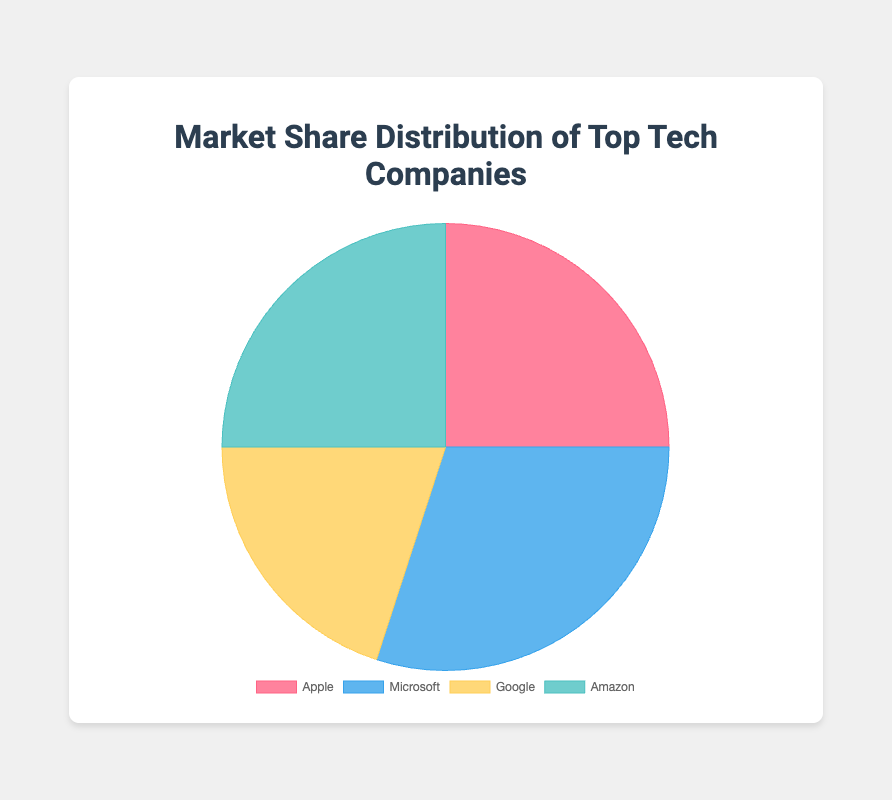What is the total market share percentage of Apple and Amazon combined? Add the market share percentages of Apple (25) and Amazon (25). 25 + 25 = 50
Answer: 50 Which company holds the highest market share? Compare the market share percentages: Apple (25), Microsoft (30), Google (20), Amazon (25). Microsoft has the highest with 30%
Answer: Microsoft What is the difference in market share between Microsoft and Google? Subtract Google's market share from Microsoft's: 30 - 20. The difference is 10
Answer: 10 Which two companies have equal market share percentages? Compare the market share percentages of all four companies. Apple and Amazon both have 25%
Answer: Apple and Amazon What is the average market share percentage of all companies? Add all the market share percentages and divide by the number of companies: (25 + 30 + 20 + 25) / 4. The average is 100 / 4 = 25
Answer: 25 Which color represents Google in the pie chart? Look at the description provided: Google's market share is represented by yellow.
Answer: Yellow How much more market share does Microsoft have compared to Apple? Subtract Apple's market share from Microsoft's: 30 - 25. The difference is 5
Answer: 5 What is the combined market share percentage of companies other than Microsoft? Add the market share percentages of Apple, Google, and Amazon: 25 + 20 + 25. The combined market share is 70
Answer: 70 Is the market share of Apple equal to the market share of Amazon? Compare the market share of Apple (25) and Amazon (25). They are equal
Answer: Yes If another company with a 10% market share is included, what will be the new average market share percentage? Add the new company's market share to the total and divide by the new number of companies: (25 + 30 + 20 + 25 + 10) / 5. The new average is 110 / 5 = 22
Answer: 22 